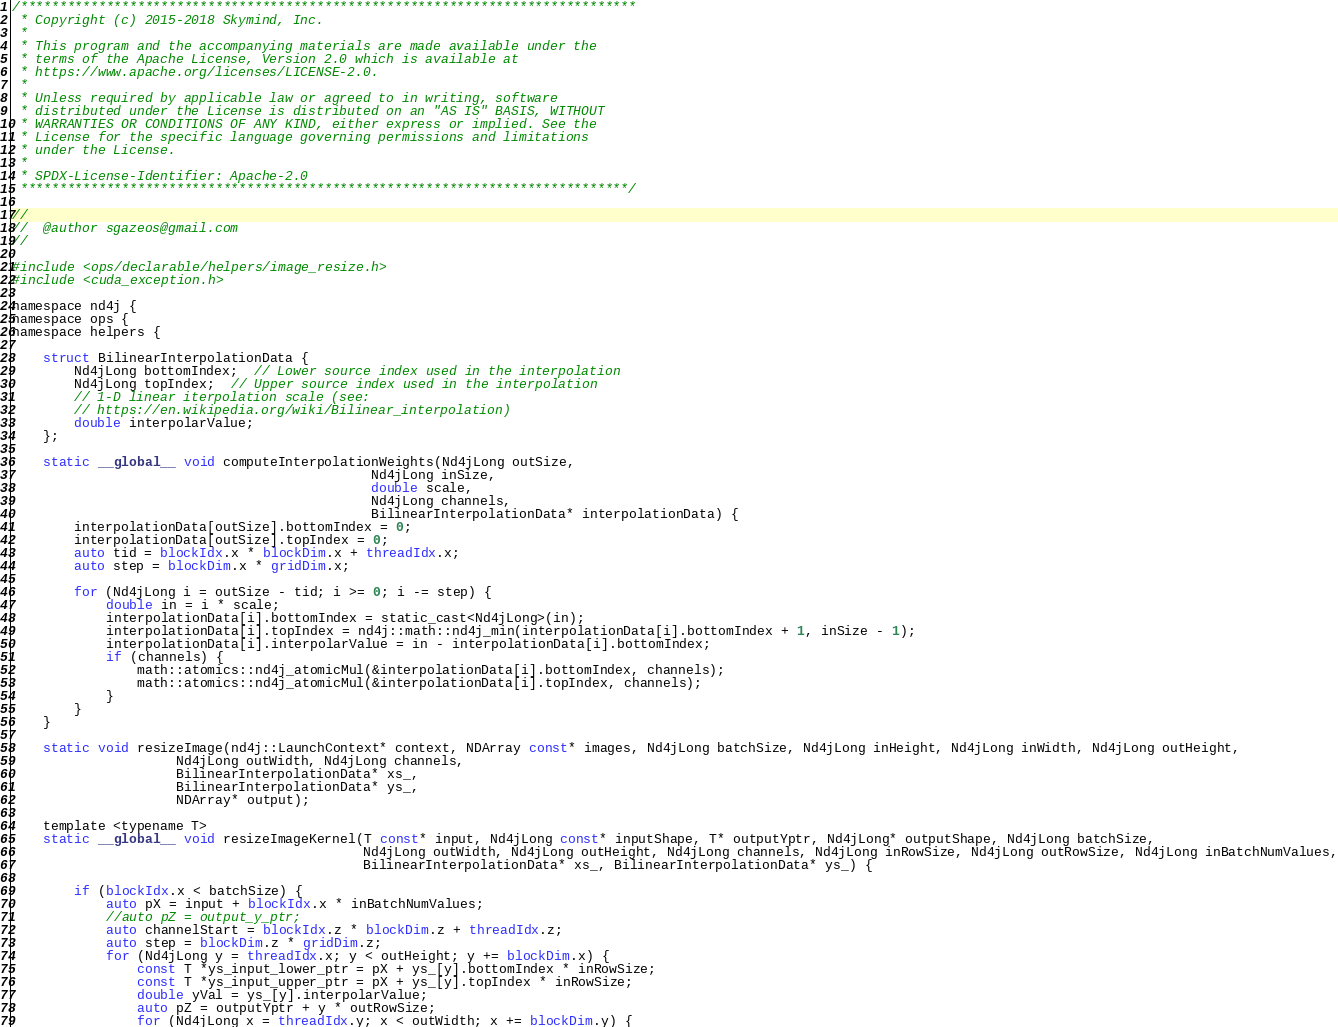Convert code to text. <code><loc_0><loc_0><loc_500><loc_500><_Cuda_>/*******************************************************************************
 * Copyright (c) 2015-2018 Skymind, Inc.
 *
 * This program and the accompanying materials are made available under the
 * terms of the Apache License, Version 2.0 which is available at
 * https://www.apache.org/licenses/LICENSE-2.0.
 *
 * Unless required by applicable law or agreed to in writing, software
 * distributed under the License is distributed on an "AS IS" BASIS, WITHOUT
 * WARRANTIES OR CONDITIONS OF ANY KIND, either express or implied. See the
 * License for the specific language governing permissions and limitations
 * under the License.
 *
 * SPDX-License-Identifier: Apache-2.0
 ******************************************************************************/

//
//  @author sgazeos@gmail.com
//

#include <ops/declarable/helpers/image_resize.h>
#include <cuda_exception.h>

namespace nd4j {
namespace ops {
namespace helpers {

    struct BilinearInterpolationData {
        Nd4jLong bottomIndex;  // Lower source index used in the interpolation
        Nd4jLong topIndex;  // Upper source index used in the interpolation
        // 1-D linear iterpolation scale (see:
        // https://en.wikipedia.org/wiki/Bilinear_interpolation)
        double interpolarValue;
    };

    static __global__ void computeInterpolationWeights(Nd4jLong outSize,
                                              Nd4jLong inSize,
                                              double scale,
                                              Nd4jLong channels,
                                              BilinearInterpolationData* interpolationData) {
        interpolationData[outSize].bottomIndex = 0;
        interpolationData[outSize].topIndex = 0;
        auto tid = blockIdx.x * blockDim.x + threadIdx.x;
        auto step = blockDim.x * gridDim.x;

        for (Nd4jLong i = outSize - tid; i >= 0; i -= step) {
            double in = i * scale;
            interpolationData[i].bottomIndex = static_cast<Nd4jLong>(in);
            interpolationData[i].topIndex = nd4j::math::nd4j_min(interpolationData[i].bottomIndex + 1, inSize - 1);
            interpolationData[i].interpolarValue = in - interpolationData[i].bottomIndex;
            if (channels) {
                math::atomics::nd4j_atomicMul(&interpolationData[i].bottomIndex, channels);
                math::atomics::nd4j_atomicMul(&interpolationData[i].topIndex, channels);
            }
        }
    }

    static void resizeImage(nd4j::LaunchContext* context, NDArray const* images, Nd4jLong batchSize, Nd4jLong inHeight, Nd4jLong inWidth, Nd4jLong outHeight,
                     Nd4jLong outWidth, Nd4jLong channels,
                     BilinearInterpolationData* xs_,
                     BilinearInterpolationData* ys_,
                     NDArray* output);

    template <typename T>
    static __global__ void resizeImageKernel(T const* input, Nd4jLong const* inputShape, T* outputYptr, Nd4jLong* outputShape, Nd4jLong batchSize,
                                             Nd4jLong outWidth, Nd4jLong outHeight, Nd4jLong channels, Nd4jLong inRowSize, Nd4jLong outRowSize, Nd4jLong inBatchNumValues,
                                             BilinearInterpolationData* xs_, BilinearInterpolationData* ys_) {

        if (blockIdx.x < batchSize) {
            auto pX = input + blockIdx.x * inBatchNumValues;
            //auto pZ = output_y_ptr;
            auto channelStart = blockIdx.z * blockDim.z + threadIdx.z;
            auto step = blockDim.z * gridDim.z;
            for (Nd4jLong y = threadIdx.x; y < outHeight; y += blockDim.x) {
                const T *ys_input_lower_ptr = pX + ys_[y].bottomIndex * inRowSize;
                const T *ys_input_upper_ptr = pX + ys_[y].topIndex * inRowSize;
                double yVal = ys_[y].interpolarValue;
                auto pZ = outputYptr + y * outRowSize;
                for (Nd4jLong x = threadIdx.y; x < outWidth; x += blockDim.y) {</code> 